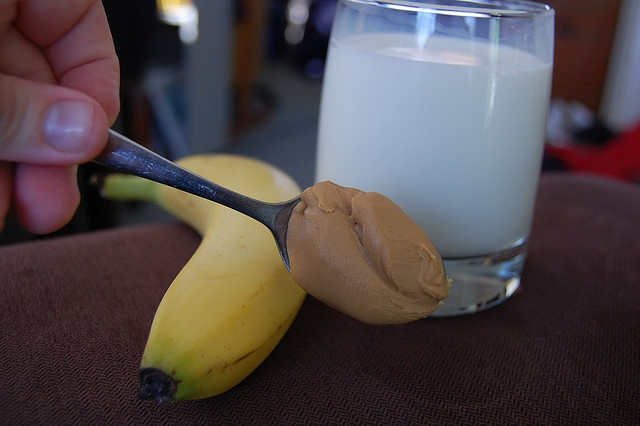Describe the objects in this image and their specific colors. I can see cup in maroon, darkgray, and gray tones, banana in maroon, tan, olive, and black tones, people in maroon, brown, purple, and black tones, and spoon in maroon, black, navy, gray, and darkblue tones in this image. 